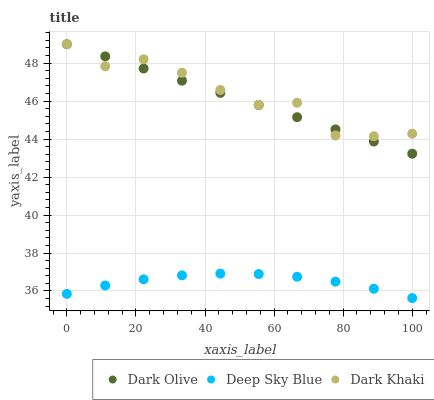Does Deep Sky Blue have the minimum area under the curve?
Answer yes or no. Yes. Does Dark Khaki have the maximum area under the curve?
Answer yes or no. Yes. Does Dark Olive have the minimum area under the curve?
Answer yes or no. No. Does Dark Olive have the maximum area under the curve?
Answer yes or no. No. Is Dark Olive the smoothest?
Answer yes or no. Yes. Is Dark Khaki the roughest?
Answer yes or no. Yes. Is Deep Sky Blue the smoothest?
Answer yes or no. No. Is Deep Sky Blue the roughest?
Answer yes or no. No. Does Deep Sky Blue have the lowest value?
Answer yes or no. Yes. Does Dark Olive have the lowest value?
Answer yes or no. No. Does Dark Olive have the highest value?
Answer yes or no. Yes. Does Deep Sky Blue have the highest value?
Answer yes or no. No. Is Deep Sky Blue less than Dark Khaki?
Answer yes or no. Yes. Is Dark Khaki greater than Deep Sky Blue?
Answer yes or no. Yes. Does Dark Khaki intersect Dark Olive?
Answer yes or no. Yes. Is Dark Khaki less than Dark Olive?
Answer yes or no. No. Is Dark Khaki greater than Dark Olive?
Answer yes or no. No. Does Deep Sky Blue intersect Dark Khaki?
Answer yes or no. No. 